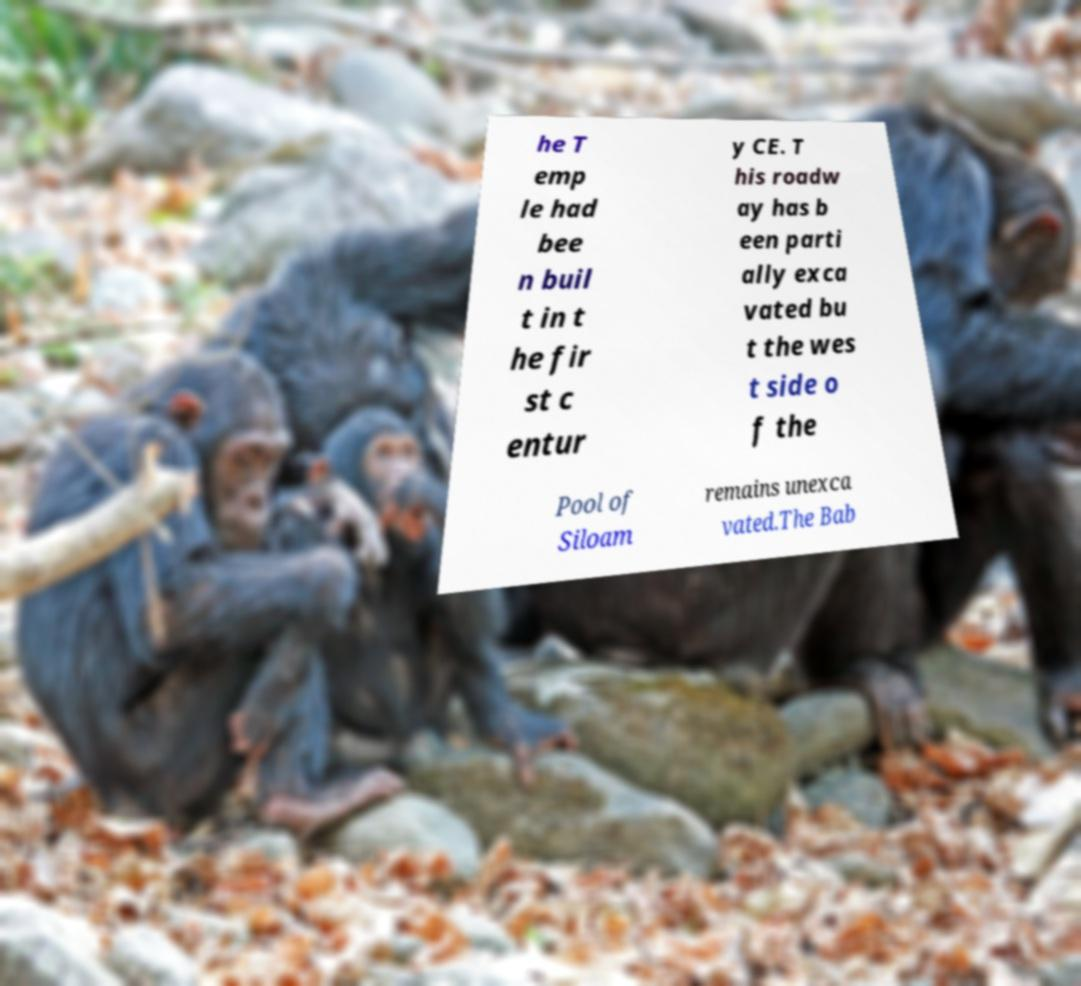Could you extract and type out the text from this image? he T emp le had bee n buil t in t he fir st c entur y CE. T his roadw ay has b een parti ally exca vated bu t the wes t side o f the Pool of Siloam remains unexca vated.The Bab 